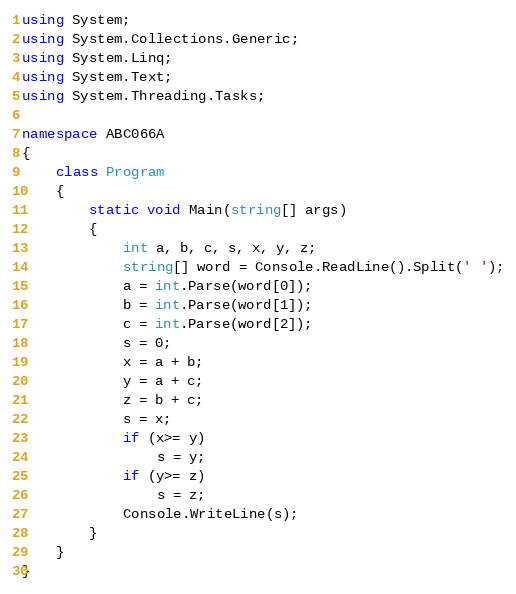Convert code to text. <code><loc_0><loc_0><loc_500><loc_500><_C#_>using System;
using System.Collections.Generic;
using System.Linq;
using System.Text;
using System.Threading.Tasks;

namespace ABC066A
{
    class Program
    {
        static void Main(string[] args)
        {
            int a, b, c, s, x, y, z;
            string[] word = Console.ReadLine().Split(' ');
            a = int.Parse(word[0]);
            b = int.Parse(word[1]);
            c = int.Parse(word[2]);
            s = 0;
            x = a + b;
            y = a + c;
            z = b + c;
            s = x;
            if (x>= y)
                s = y;
            if (y>= z)
                s = z;
            Console.WriteLine(s);
        }
    }
}</code> 